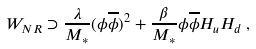<formula> <loc_0><loc_0><loc_500><loc_500>W _ { N R } \supset \frac { \lambda } { M _ { * } } ( \phi \overline { \phi } ) ^ { 2 } + \frac { \beta } { M _ { * } } \phi \overline { \phi } H _ { u } H _ { d } \, ,</formula> 